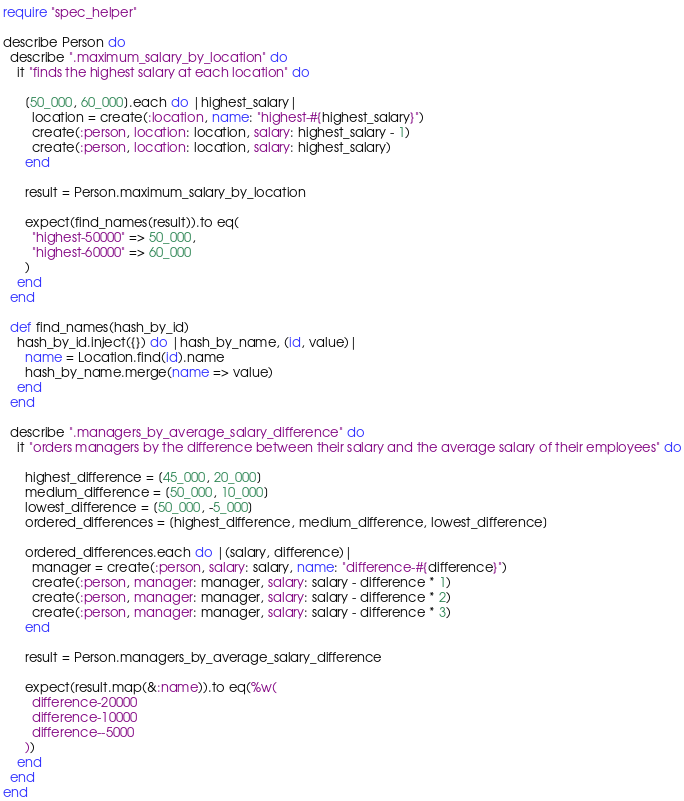Convert code to text. <code><loc_0><loc_0><loc_500><loc_500><_Ruby_>require "spec_helper"

describe Person do
  describe ".maximum_salary_by_location" do
    it "finds the highest salary at each location" do

      [50_000, 60_000].each do |highest_salary|
        location = create(:location, name: "highest-#{highest_salary}")
        create(:person, location: location, salary: highest_salary - 1)
        create(:person, location: location, salary: highest_salary)
      end

      result = Person.maximum_salary_by_location

      expect(find_names(result)).to eq(
        "highest-50000" => 50_000,
        "highest-60000" => 60_000
      )
    end
  end

  def find_names(hash_by_id)
    hash_by_id.inject({}) do |hash_by_name, (id, value)|
      name = Location.find(id).name
      hash_by_name.merge(name => value)
    end
  end

  describe ".managers_by_average_salary_difference" do
    it "orders managers by the difference between their salary and the average salary of their employees" do

      highest_difference = [45_000, 20_000]
      medium_difference = [50_000, 10_000]
      lowest_difference = [50_000, -5_000]
      ordered_differences = [highest_difference, medium_difference, lowest_difference]

      ordered_differences.each do |(salary, difference)|
        manager = create(:person, salary: salary, name: "difference-#{difference}")
        create(:person, manager: manager, salary: salary - difference * 1)
        create(:person, manager: manager, salary: salary - difference * 2)
        create(:person, manager: manager, salary: salary - difference * 3)
      end

      result = Person.managers_by_average_salary_difference

      expect(result.map(&:name)).to eq(%w(
        difference-20000
        difference-10000
        difference--5000
      ))
    end
  end
end
</code> 